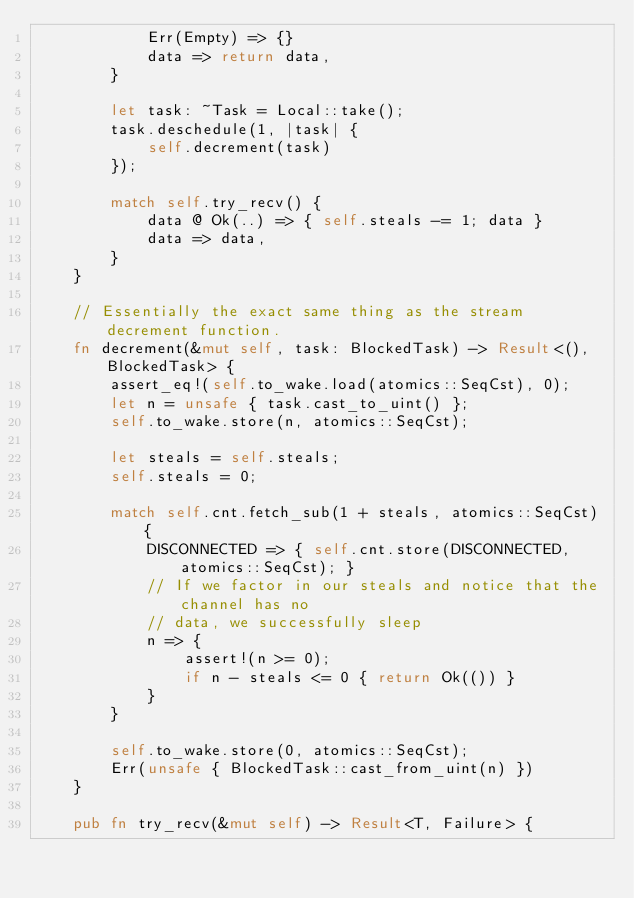<code> <loc_0><loc_0><loc_500><loc_500><_Rust_>            Err(Empty) => {}
            data => return data,
        }

        let task: ~Task = Local::take();
        task.deschedule(1, |task| {
            self.decrement(task)
        });

        match self.try_recv() {
            data @ Ok(..) => { self.steals -= 1; data }
            data => data,
        }
    }

    // Essentially the exact same thing as the stream decrement function.
    fn decrement(&mut self, task: BlockedTask) -> Result<(), BlockedTask> {
        assert_eq!(self.to_wake.load(atomics::SeqCst), 0);
        let n = unsafe { task.cast_to_uint() };
        self.to_wake.store(n, atomics::SeqCst);

        let steals = self.steals;
        self.steals = 0;

        match self.cnt.fetch_sub(1 + steals, atomics::SeqCst) {
            DISCONNECTED => { self.cnt.store(DISCONNECTED, atomics::SeqCst); }
            // If we factor in our steals and notice that the channel has no
            // data, we successfully sleep
            n => {
                assert!(n >= 0);
                if n - steals <= 0 { return Ok(()) }
            }
        }

        self.to_wake.store(0, atomics::SeqCst);
        Err(unsafe { BlockedTask::cast_from_uint(n) })
    }

    pub fn try_recv(&mut self) -> Result<T, Failure> {</code> 